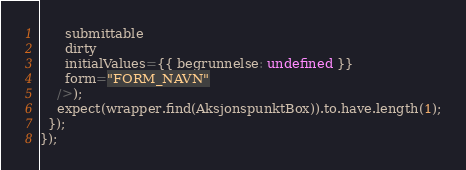<code> <loc_0><loc_0><loc_500><loc_500><_TypeScript_>      submittable
      dirty
      initialValues={{ begrunnelse: undefined }}
      form="FORM_NAVN"
    />);
    expect(wrapper.find(AksjonspunktBox)).to.have.length(1);
  });
});
</code> 